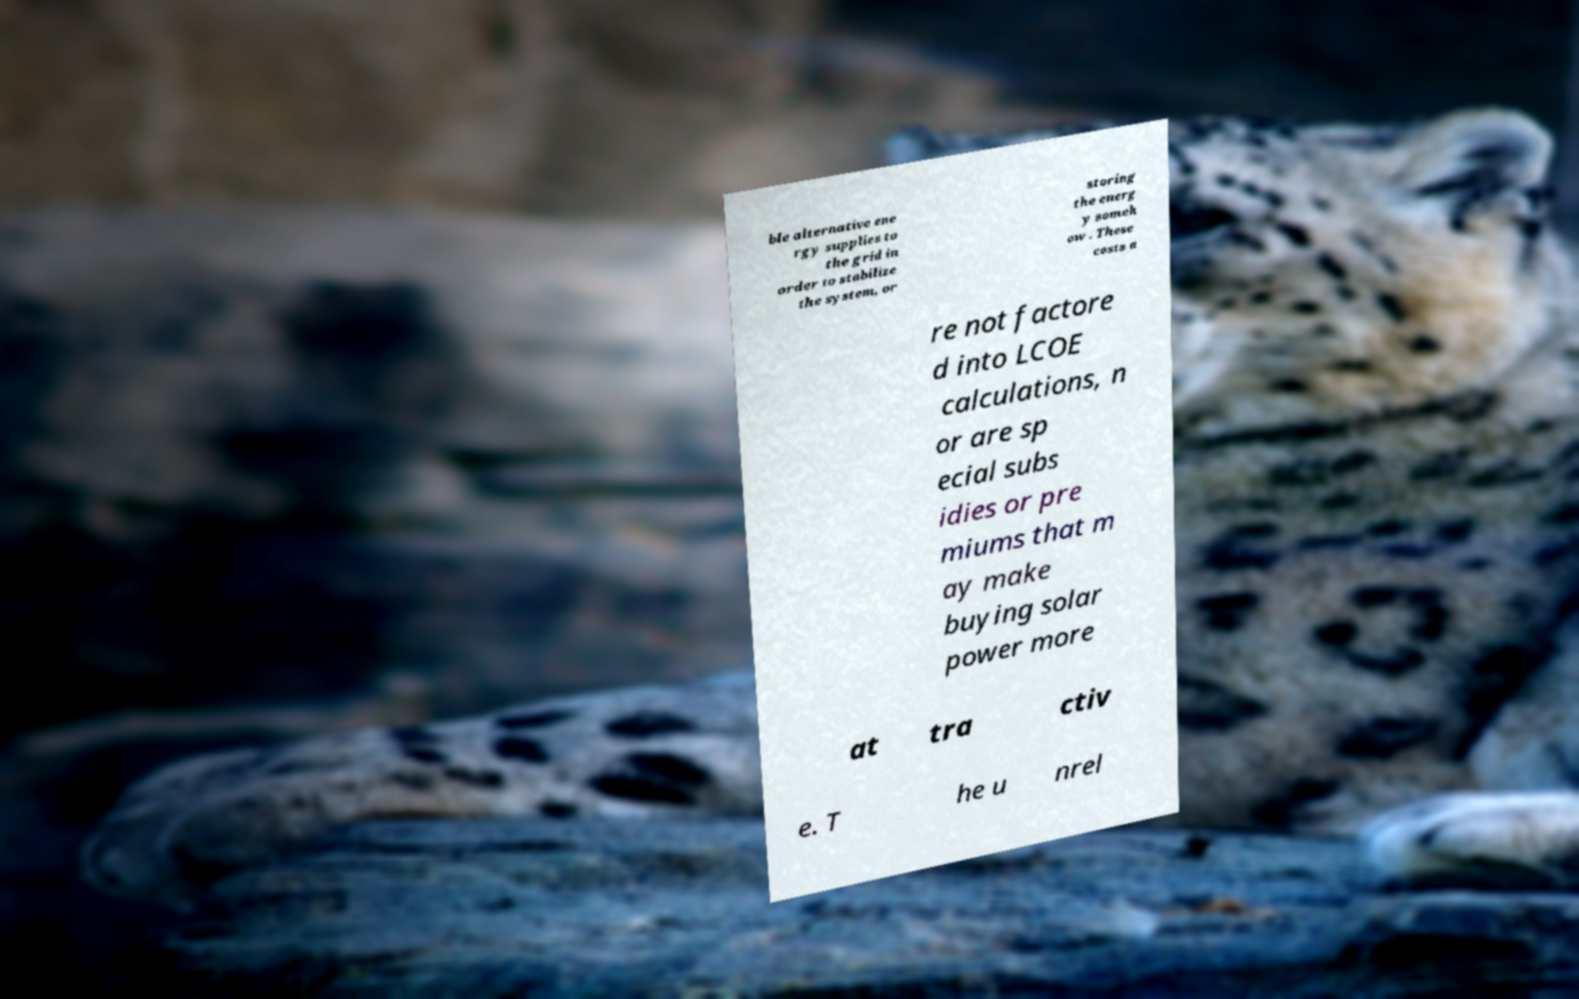For documentation purposes, I need the text within this image transcribed. Could you provide that? ble alternative ene rgy supplies to the grid in order to stabilize the system, or storing the energ y someh ow . These costs a re not factore d into LCOE calculations, n or are sp ecial subs idies or pre miums that m ay make buying solar power more at tra ctiv e. T he u nrel 